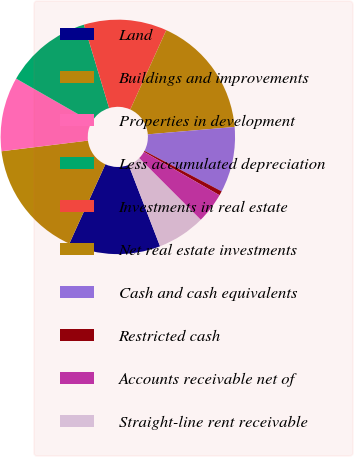<chart> <loc_0><loc_0><loc_500><loc_500><pie_chart><fcel>Land<fcel>Buildings and improvements<fcel>Properties in development<fcel>Less accumulated depreciation<fcel>Investments in real estate<fcel>Net real estate investments<fcel>Cash and cash equivalents<fcel>Restricted cash<fcel>Accounts receivable net of<fcel>Straight-line rent receivable<nl><fcel>12.65%<fcel>16.26%<fcel>10.24%<fcel>12.05%<fcel>11.45%<fcel>16.87%<fcel>9.04%<fcel>0.6%<fcel>4.22%<fcel>6.63%<nl></chart> 